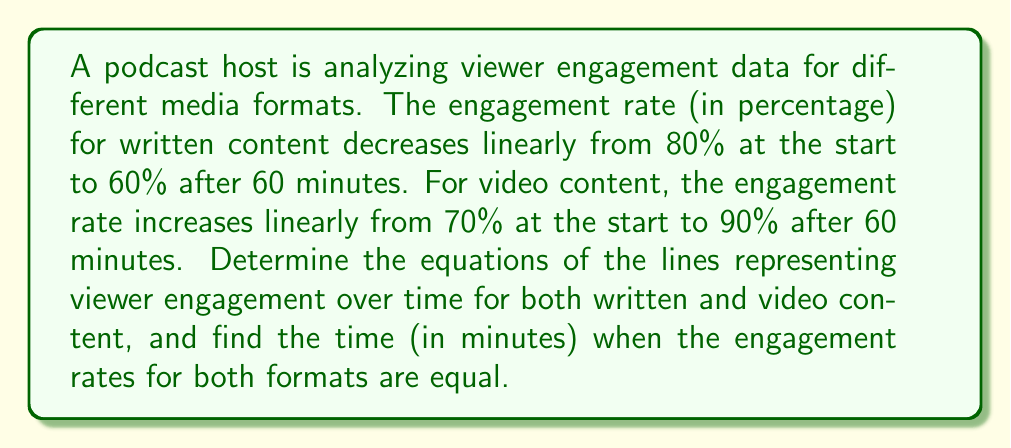What is the answer to this math problem? 1. For written content:
   - Initial point: $(0, 80)$
   - Final point: $(60, 60)$
   
   Slope: $m_1 = \frac{60 - 80}{60 - 0} = -\frac{1}{3}$
   
   Equation: $y = m_1x + b_1$
   $80 = -\frac{1}{3}(0) + b_1$
   $b_1 = 80$
   
   Written content equation: $y = -\frac{1}{3}x + 80$

2. For video content:
   - Initial point: $(0, 70)$
   - Final point: $(60, 90)$
   
   Slope: $m_2 = \frac{90 - 70}{60 - 0} = \frac{1}{3}$
   
   Equation: $y = m_2x + b_2$
   $70 = \frac{1}{3}(0) + b_2$
   $b_2 = 70$
   
   Video content equation: $y = \frac{1}{3}x + 70$

3. To find the intersection point:
   $$-\frac{1}{3}x + 80 = \frac{1}{3}x + 70$$
   $$-\frac{2}{3}x = -10$$
   $$x = 15$$

   Substitute $x = 15$ into either equation:
   $$y = -\frac{1}{3}(15) + 80 = 75$$

Therefore, the engagement rates are equal at $(15, 75)$, or after 15 minutes at 75% engagement.
Answer: Written: $y = -\frac{1}{3}x + 80$, Video: $y = \frac{1}{3}x + 70$, Intersection: 15 minutes 